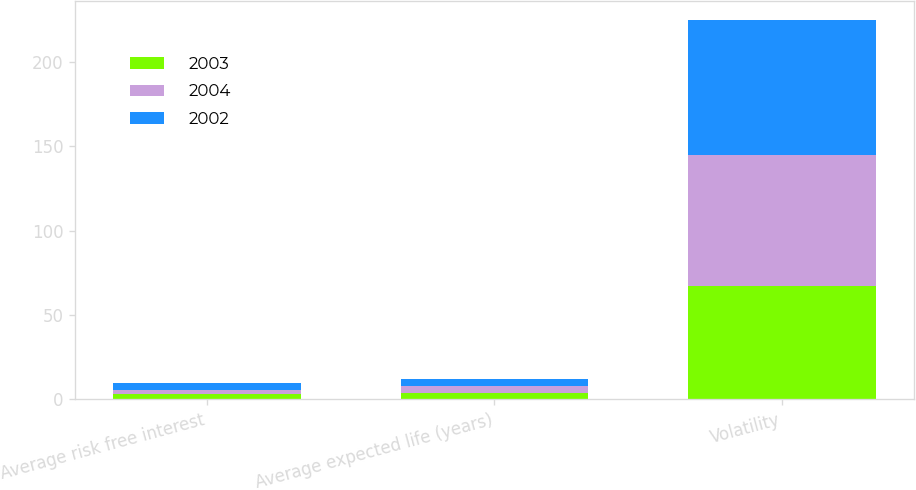Convert chart to OTSL. <chart><loc_0><loc_0><loc_500><loc_500><stacked_bar_chart><ecel><fcel>Average risk free interest<fcel>Average expected life (years)<fcel>Volatility<nl><fcel>2003<fcel>3.14<fcel>4<fcel>67<nl><fcel>2004<fcel>2.52<fcel>4<fcel>78<nl><fcel>2002<fcel>3.9<fcel>4<fcel>80<nl></chart> 